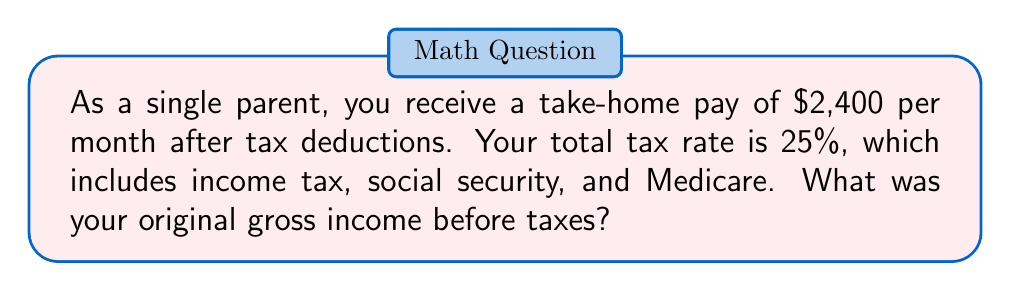Can you answer this question? Let's approach this step-by-step:

1) Let $x$ be the original gross income.

2) The take-home pay is 75% of the gross income (because 25% is deducted for taxes).
   We can express this as an equation:
   $$2400 = 0.75x$$

3) To solve for $x$, divide both sides by 0.75:
   $$\frac{2400}{0.75} = x$$

4) Simplify:
   $$3200 = x$$

5) To verify:
   - 25% of 3200 is $3200 * 0.25 = 800$ (taxes)
   - $3200 - 800 = 2400$ (take-home pay)

Therefore, the original gross income was $3,200 per month.
Answer: $3,200 per month 